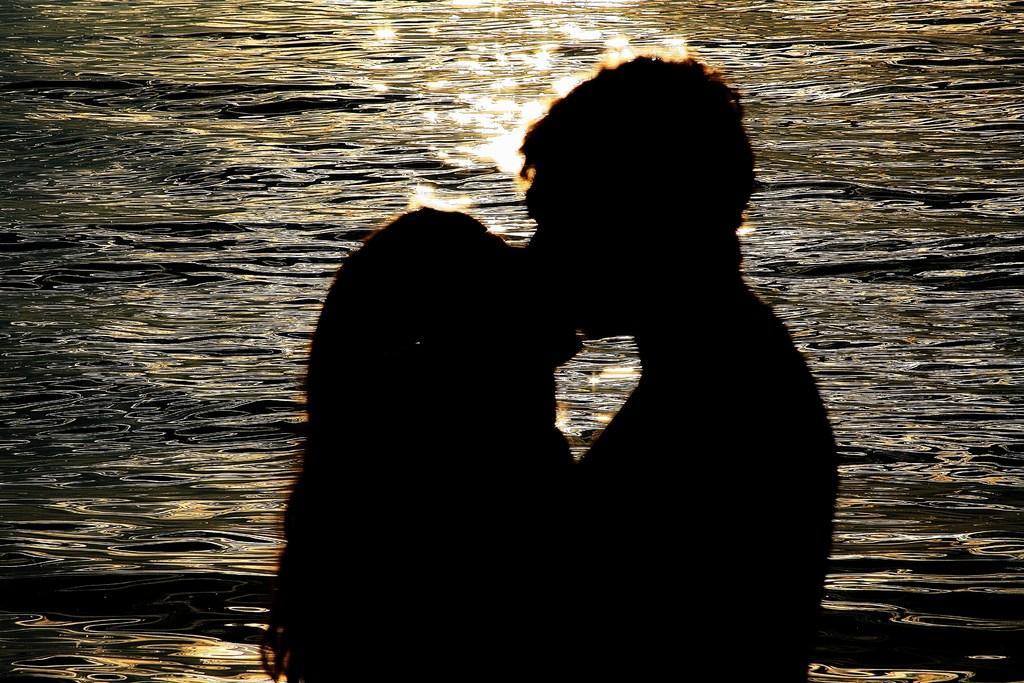In one or two sentences, can you explain what this image depicts? In this image we can see a couple kissing on the sea shore. 